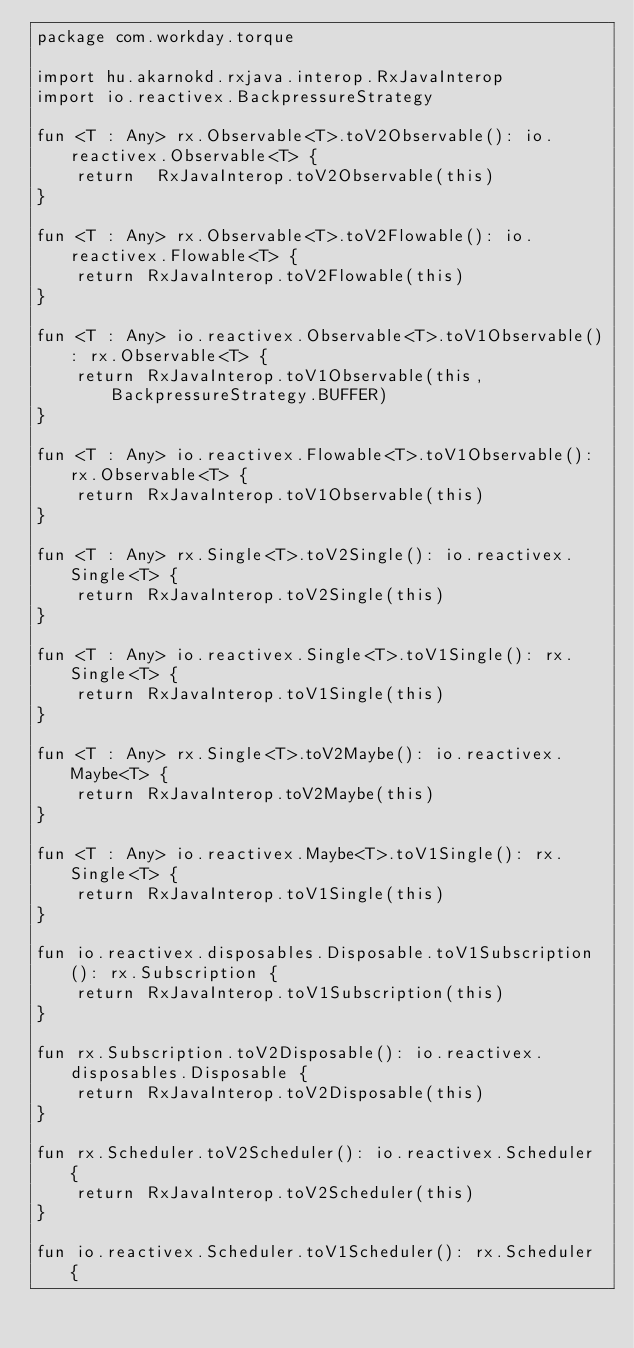<code> <loc_0><loc_0><loc_500><loc_500><_Kotlin_>package com.workday.torque

import hu.akarnokd.rxjava.interop.RxJavaInterop
import io.reactivex.BackpressureStrategy

fun <T : Any> rx.Observable<T>.toV2Observable(): io.reactivex.Observable<T> {
    return  RxJavaInterop.toV2Observable(this)
}

fun <T : Any> rx.Observable<T>.toV2Flowable(): io.reactivex.Flowable<T> {
    return RxJavaInterop.toV2Flowable(this)
}

fun <T : Any> io.reactivex.Observable<T>.toV1Observable(): rx.Observable<T> {
    return RxJavaInterop.toV1Observable(this, BackpressureStrategy.BUFFER)
}

fun <T : Any> io.reactivex.Flowable<T>.toV1Observable(): rx.Observable<T> {
    return RxJavaInterop.toV1Observable(this)
}

fun <T : Any> rx.Single<T>.toV2Single(): io.reactivex.Single<T> {
    return RxJavaInterop.toV2Single(this)
}

fun <T : Any> io.reactivex.Single<T>.toV1Single(): rx.Single<T> {
    return RxJavaInterop.toV1Single(this)
}

fun <T : Any> rx.Single<T>.toV2Maybe(): io.reactivex.Maybe<T> {
    return RxJavaInterop.toV2Maybe(this)
}

fun <T : Any> io.reactivex.Maybe<T>.toV1Single(): rx.Single<T> {
    return RxJavaInterop.toV1Single(this)
}

fun io.reactivex.disposables.Disposable.toV1Subscription(): rx.Subscription {
    return RxJavaInterop.toV1Subscription(this)
}

fun rx.Subscription.toV2Disposable(): io.reactivex.disposables.Disposable {
    return RxJavaInterop.toV2Disposable(this)
}

fun rx.Scheduler.toV2Scheduler(): io.reactivex.Scheduler {
    return RxJavaInterop.toV2Scheduler(this)
}

fun io.reactivex.Scheduler.toV1Scheduler(): rx.Scheduler {</code> 